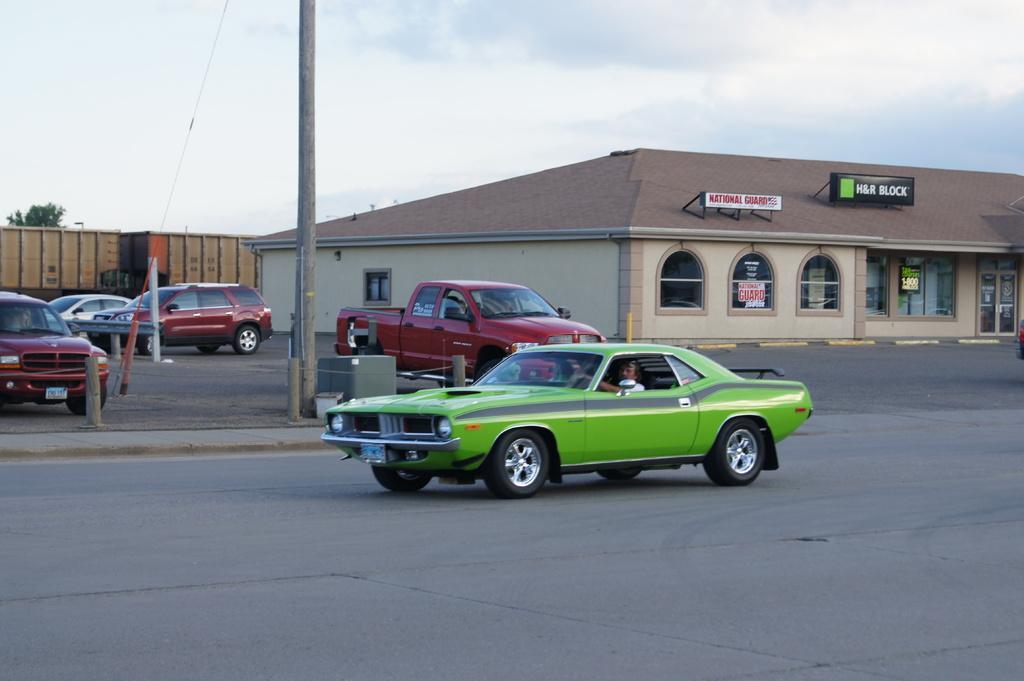Describe this image in one or two sentences. In this image we can see sky with clouds, street poles, containers, buildings, name boards and motor vehicles on the road. 